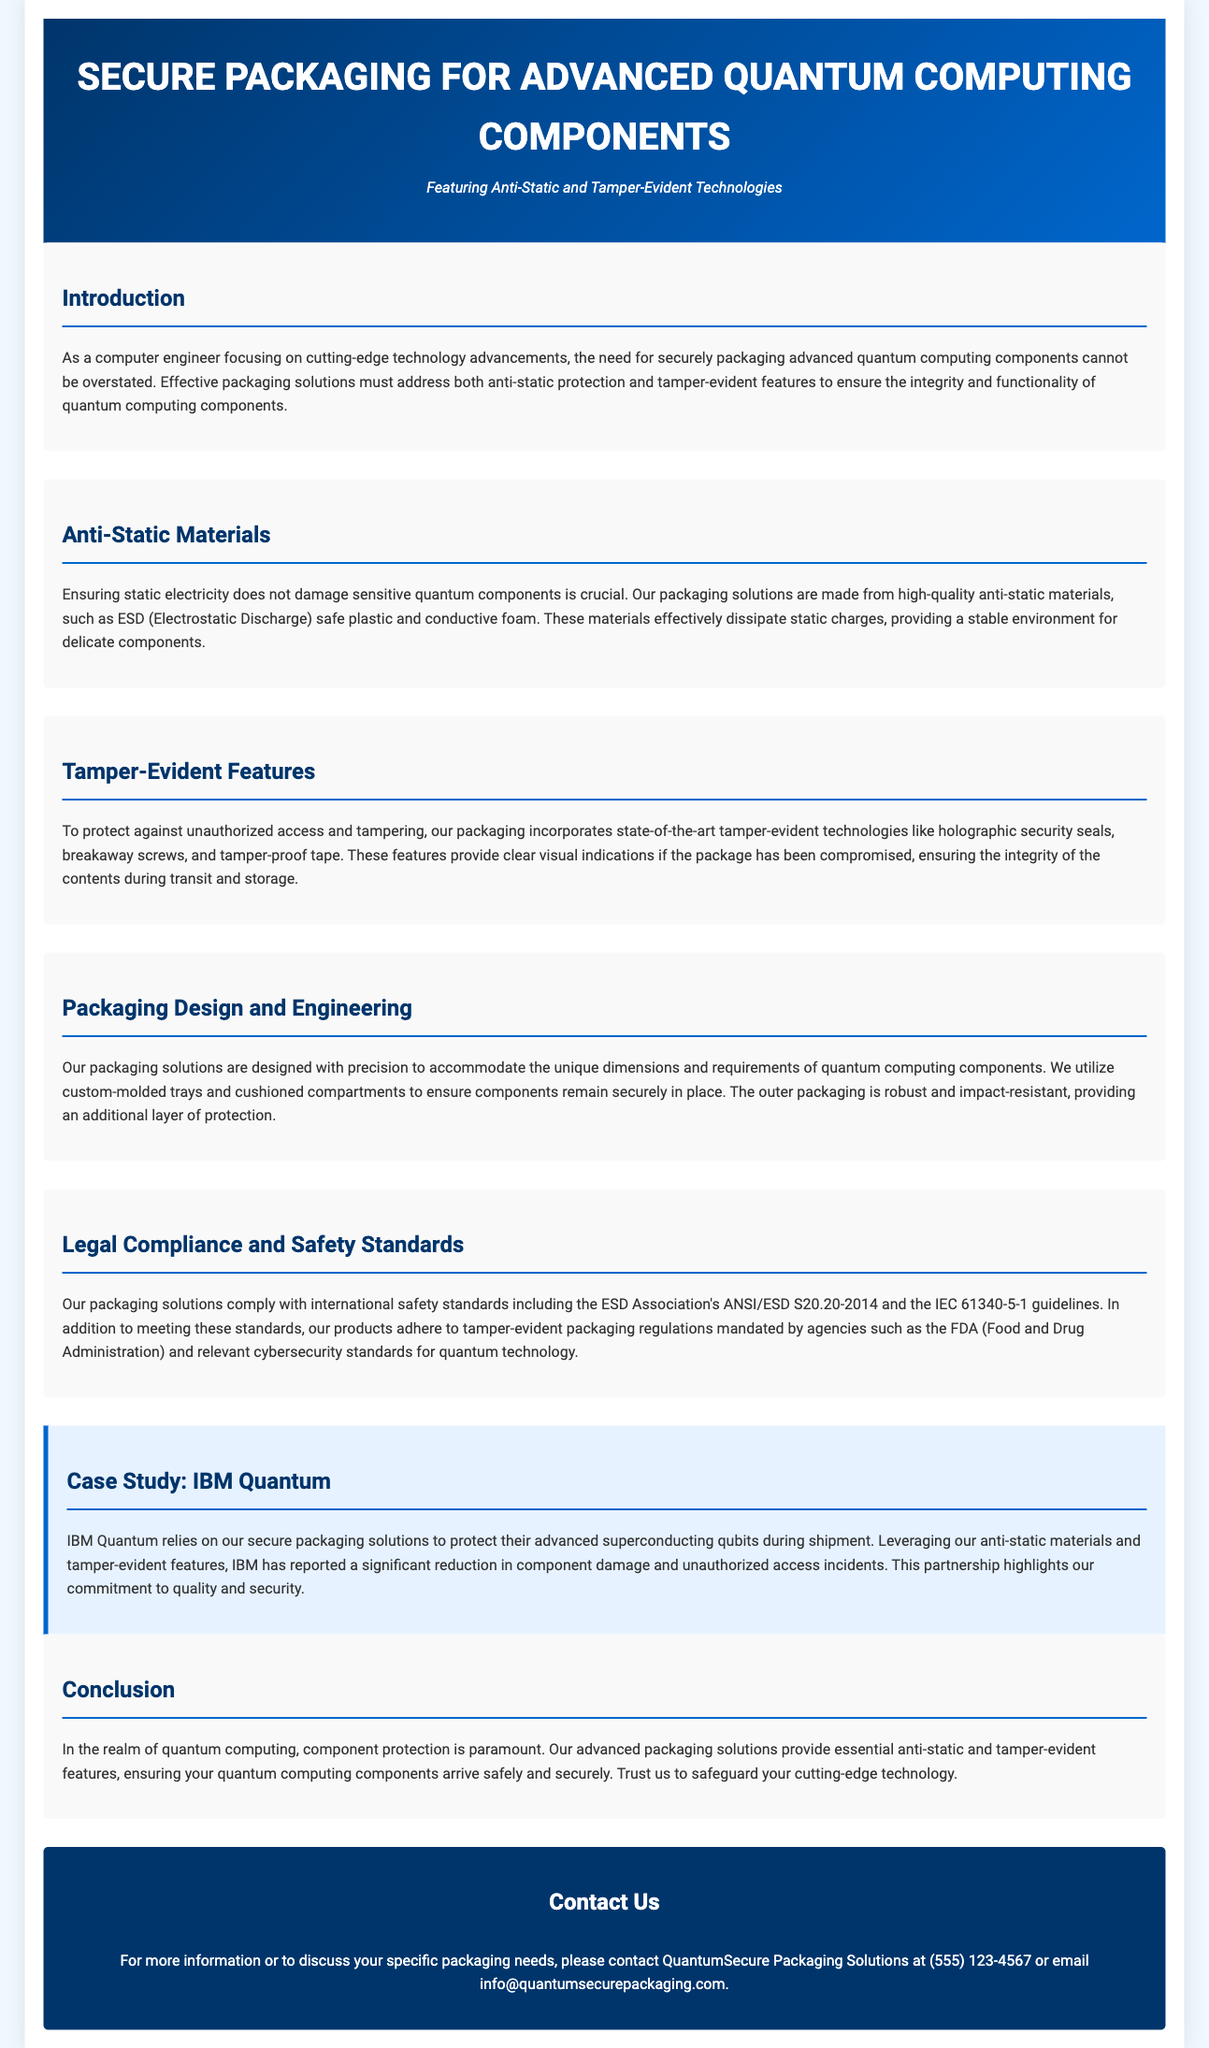What is the main focus of the document? The main focus of the document is on packaging for advanced quantum computing components.
Answer: packaging for advanced quantum computing components What materials are used for anti-static protection? The document mentions high-quality anti-static materials like ESD safe plastic and conductive foam.
Answer: ESD safe plastic and conductive foam Which company uses the packaging solutions? The case study highlights IBM Quantum as a user of the packaging solutions.
Answer: IBM Quantum What technology is mentioned for tamper-evident features? The document lists holographic security seals, breakaway screws, and tamper-proof tape as tamper-evident technologies.
Answer: holographic security seals, breakaway screws, and tamper-proof tape What safety standards do the packaging solutions comply with? The document states compliance with ANSI/ESD S20.20-2014 and IEC 61340-5-1 guidelines.
Answer: ANSI/ESD S20.20-2014 and IEC 61340-5-1 How does the packaging ensure components remain in place? The packaging features custom-molded trays and cushioned compartments to secure components.
Answer: custom-molded trays and cushioned compartments What type of marketing material is this document classified as? This document is classified as product packaging material.
Answer: product packaging material 